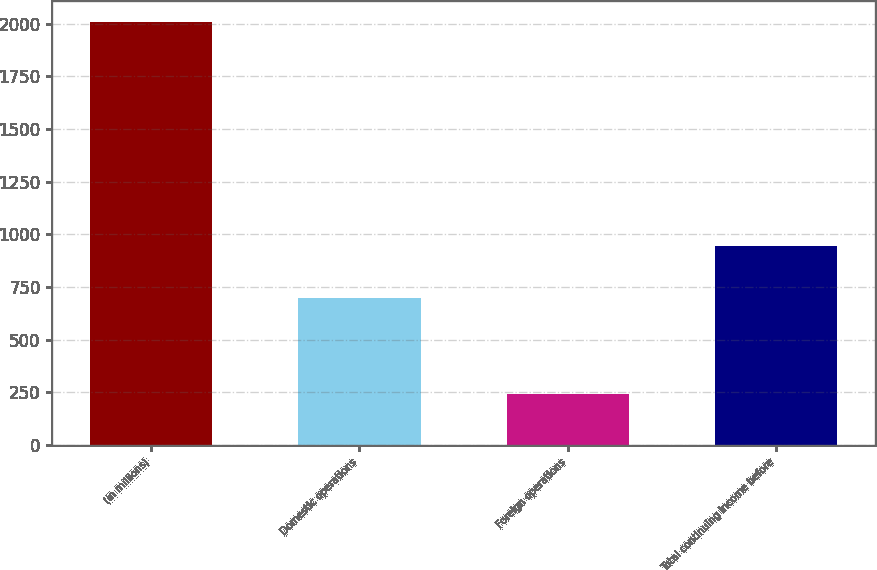Convert chart to OTSL. <chart><loc_0><loc_0><loc_500><loc_500><bar_chart><fcel>(in millions)<fcel>Domestic operations<fcel>Foreign operations<fcel>Total continuing income before<nl><fcel>2010<fcel>699<fcel>244<fcel>943<nl></chart> 